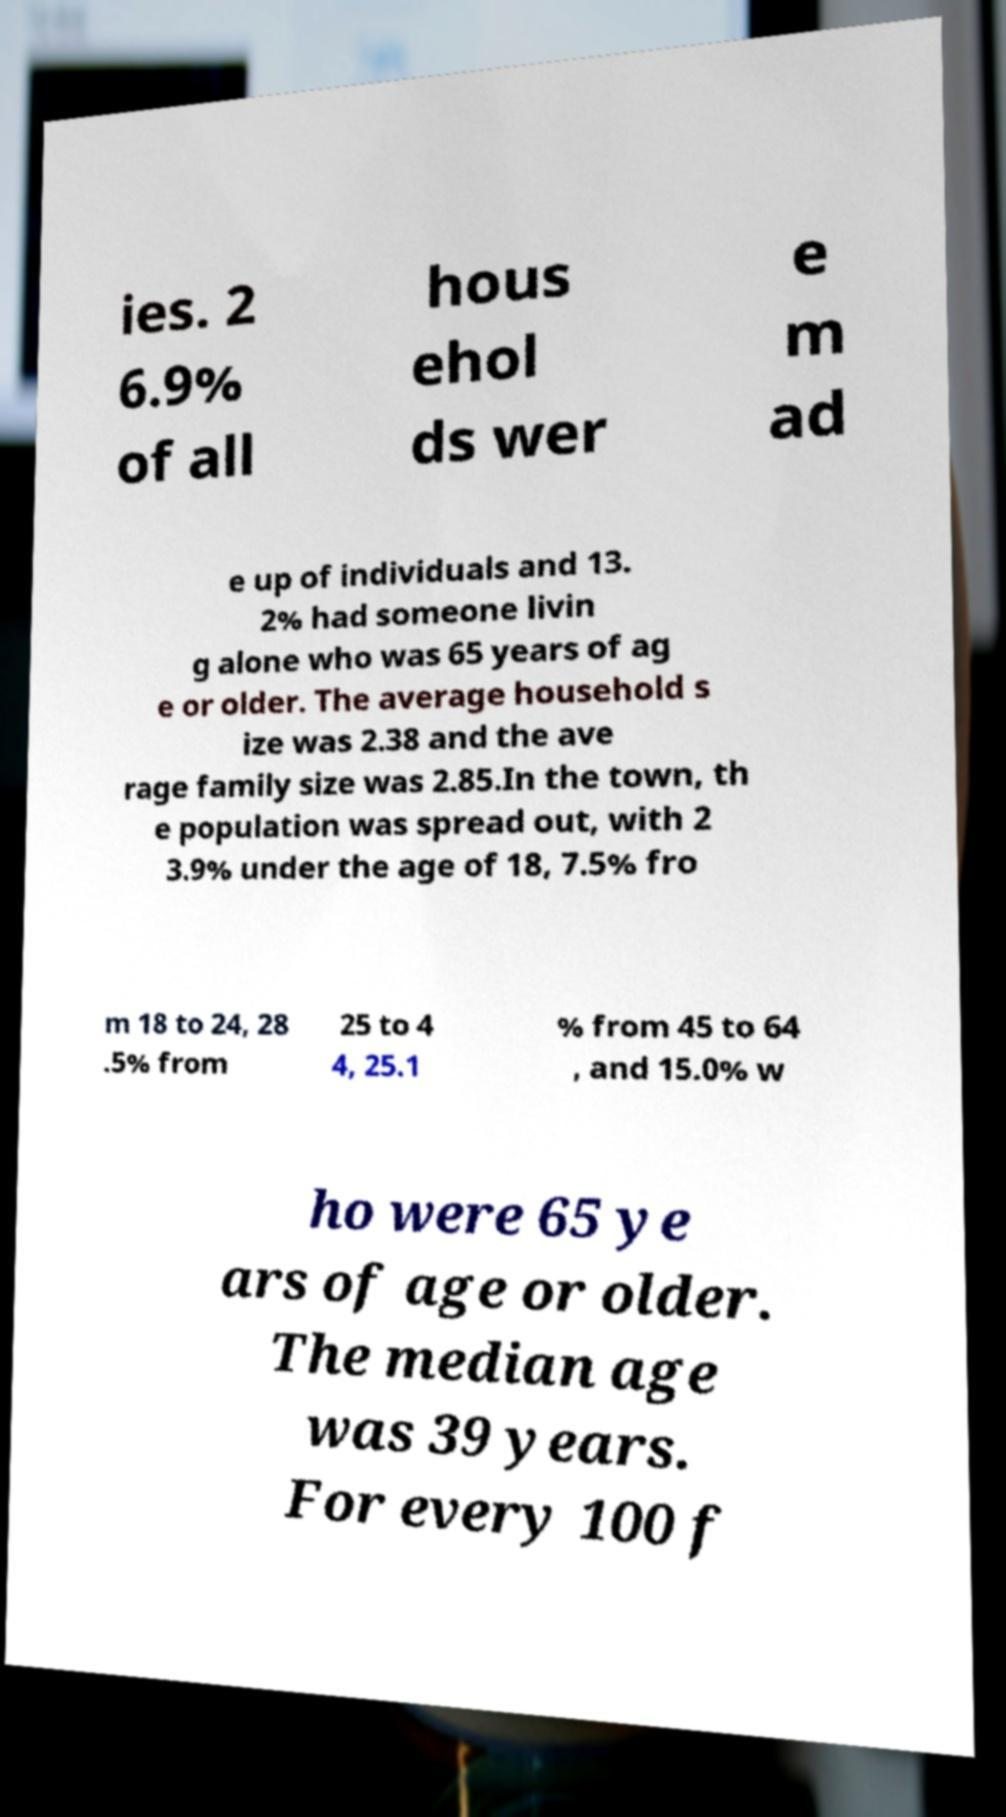There's text embedded in this image that I need extracted. Can you transcribe it verbatim? ies. 2 6.9% of all hous ehol ds wer e m ad e up of individuals and 13. 2% had someone livin g alone who was 65 years of ag e or older. The average household s ize was 2.38 and the ave rage family size was 2.85.In the town, th e population was spread out, with 2 3.9% under the age of 18, 7.5% fro m 18 to 24, 28 .5% from 25 to 4 4, 25.1 % from 45 to 64 , and 15.0% w ho were 65 ye ars of age or older. The median age was 39 years. For every 100 f 